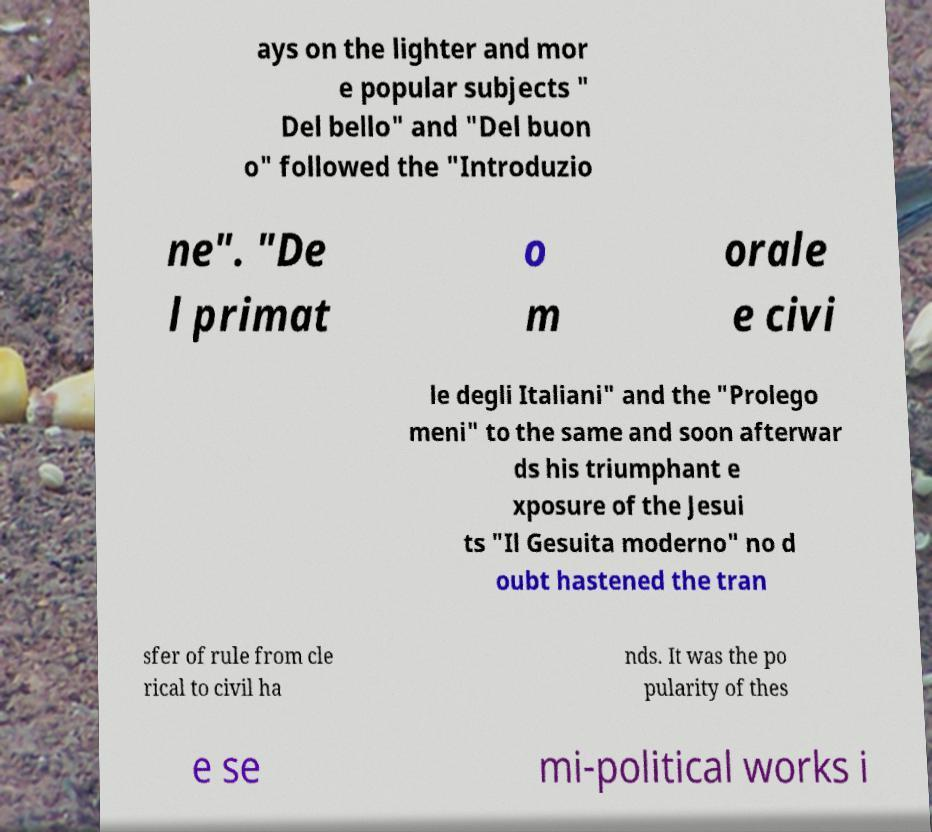Please identify and transcribe the text found in this image. ays on the lighter and mor e popular subjects " Del bello" and "Del buon o" followed the "Introduzio ne". "De l primat o m orale e civi le degli Italiani" and the "Prolego meni" to the same and soon afterwar ds his triumphant e xposure of the Jesui ts "Il Gesuita moderno" no d oubt hastened the tran sfer of rule from cle rical to civil ha nds. It was the po pularity of thes e se mi-political works i 